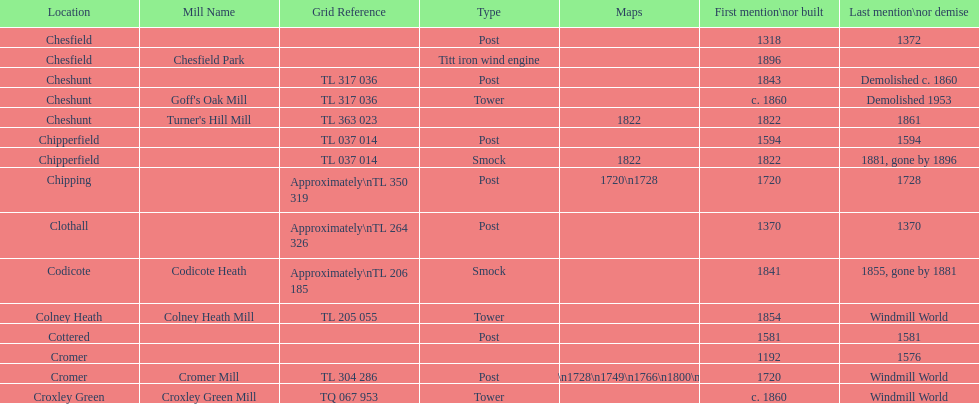How many locations have or had at least 2 windmills? 4. 